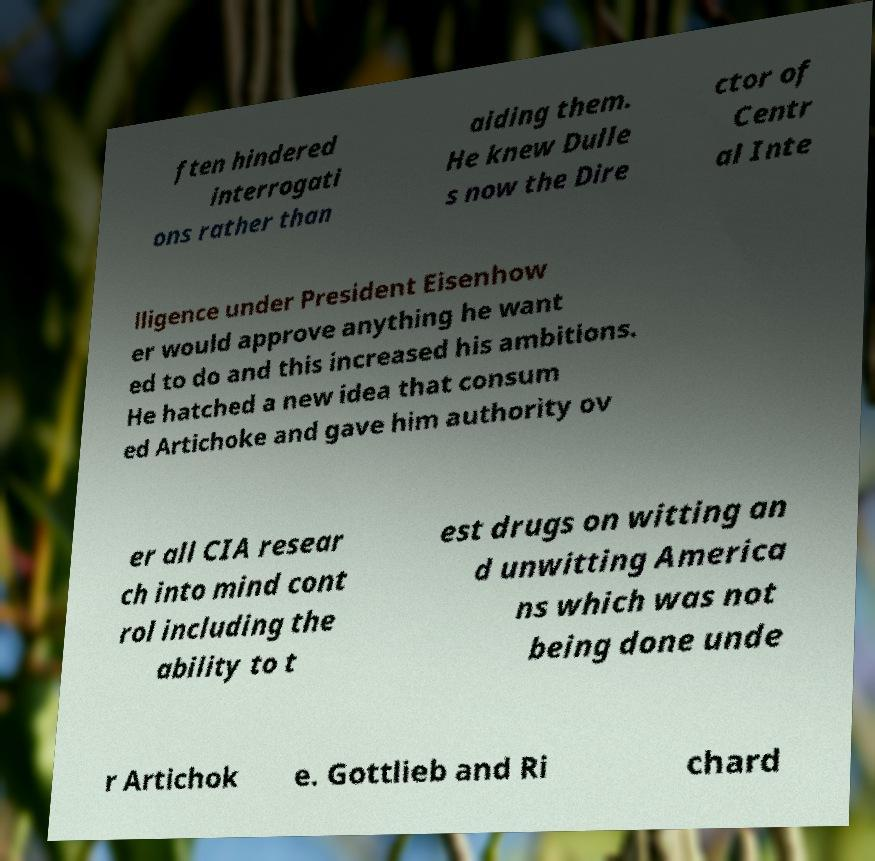Can you read and provide the text displayed in the image?This photo seems to have some interesting text. Can you extract and type it out for me? ften hindered interrogati ons rather than aiding them. He knew Dulle s now the Dire ctor of Centr al Inte lligence under President Eisenhow er would approve anything he want ed to do and this increased his ambitions. He hatched a new idea that consum ed Artichoke and gave him authority ov er all CIA resear ch into mind cont rol including the ability to t est drugs on witting an d unwitting America ns which was not being done unde r Artichok e. Gottlieb and Ri chard 